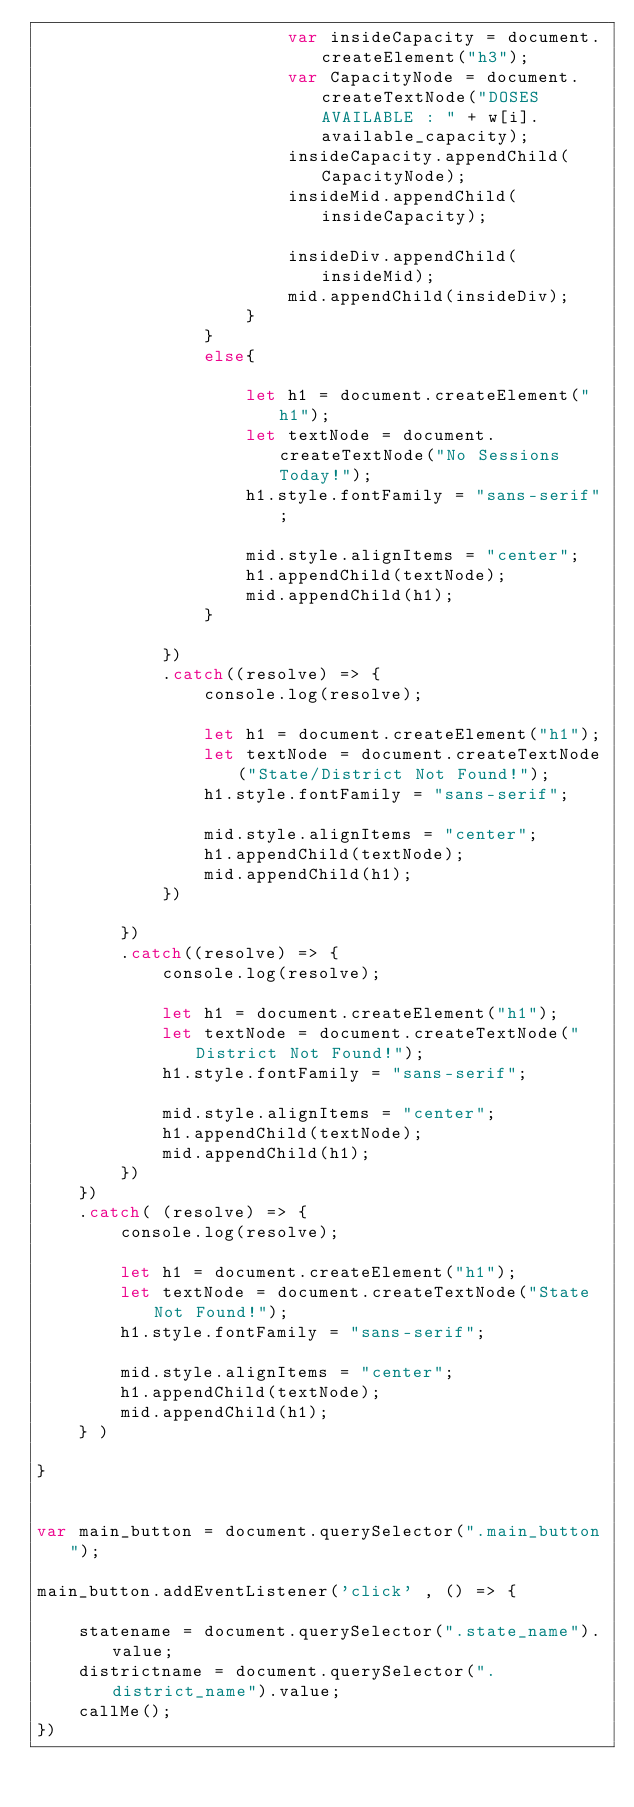<code> <loc_0><loc_0><loc_500><loc_500><_JavaScript_>                        var insideCapacity = document.createElement("h3");
                        var CapacityNode = document.createTextNode("DOSES AVAILABLE : " + w[i].available_capacity);
                        insideCapacity.appendChild(CapacityNode);
                        insideMid.appendChild(insideCapacity);
    
                        insideDiv.appendChild(insideMid);
                        mid.appendChild(insideDiv);
                    }
                }
                else{
                    
                    let h1 = document.createElement("h1");
                    let textNode = document.createTextNode("No Sessions Today!");
                    h1.style.fontFamily = "sans-serif";
        
                    mid.style.alignItems = "center";
                    h1.appendChild(textNode);
                    mid.appendChild(h1);
                }
                
            })
            .catch((resolve) => {
                console.log(resolve);

                let h1 = document.createElement("h1");
                let textNode = document.createTextNode("State/District Not Found!");
                h1.style.fontFamily = "sans-serif";
    
                mid.style.alignItems = "center";
                h1.appendChild(textNode);
                mid.appendChild(h1);
            })

        })
        .catch((resolve) => {
            console.log(resolve);

            let h1 = document.createElement("h1");
            let textNode = document.createTextNode("District Not Found!");
            h1.style.fontFamily = "sans-serif";

            mid.style.alignItems = "center";
            h1.appendChild(textNode);
            mid.appendChild(h1);
        })
    })
    .catch( (resolve) => {
        console.log(resolve);

        let h1 = document.createElement("h1");
        let textNode = document.createTextNode("State Not Found!");
        h1.style.fontFamily = "sans-serif";

        mid.style.alignItems = "center";
        h1.appendChild(textNode);
        mid.appendChild(h1);
    } )

}


var main_button = document.querySelector(".main_button");

main_button.addEventListener('click' , () => {

    statename = document.querySelector(".state_name").value;
    districtname = document.querySelector(".district_name").value;
    callMe();
})</code> 